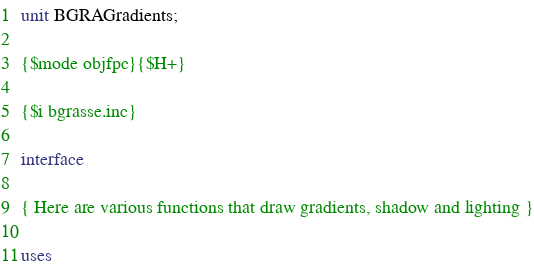Convert code to text. <code><loc_0><loc_0><loc_500><loc_500><_Pascal_>unit BGRAGradients;

{$mode objfpc}{$H+}

{$i bgrasse.inc}

interface

{ Here are various functions that draw gradients, shadow and lighting }

uses</code> 